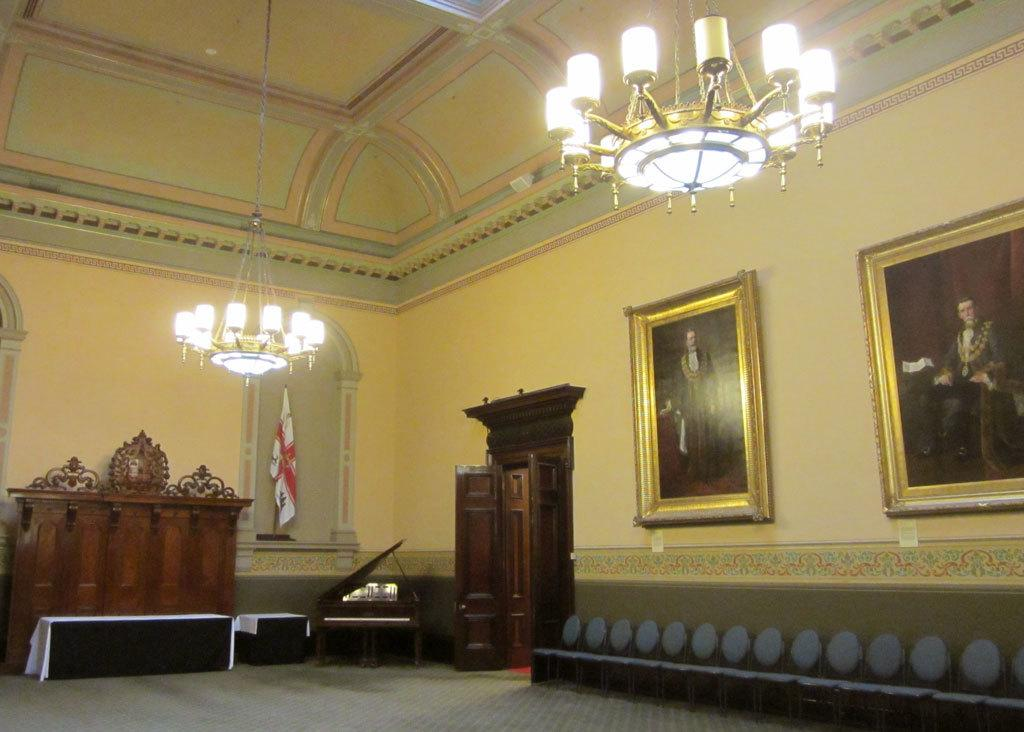What type of seating is present in the image? There are chairs in the image. What other types of furniture can be seen in the image? There is a piano on the floor. What is the purpose of the door in the image? The door in the image provides access to another room or area. What is hanging on the wall in the image? There is a flag and frames on the wall. What is visible at the top of the image? There are lights visible at the top of the image. Can you tell me how many people are exchanging haircuts in the image? There is no exchange of haircuts or any people involved in haircuts in the image. What type of lift is present in the image? There is no lift present in the image. 